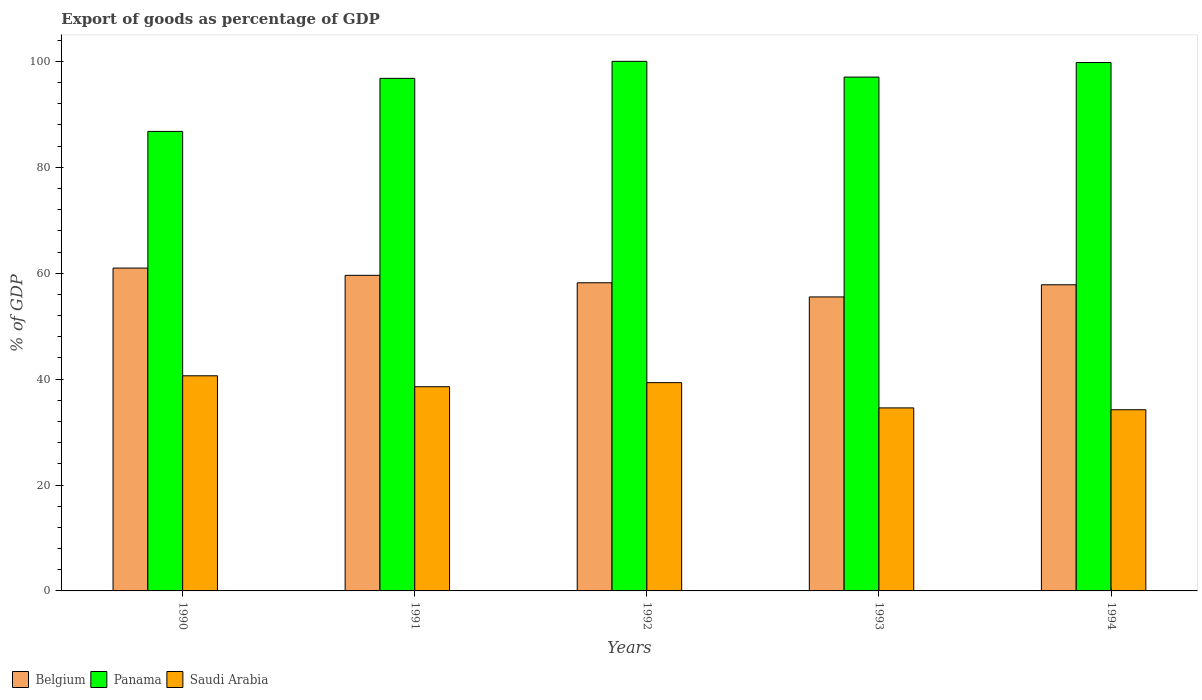Are the number of bars on each tick of the X-axis equal?
Make the answer very short. Yes. How many bars are there on the 1st tick from the right?
Your answer should be very brief. 3. In how many cases, is the number of bars for a given year not equal to the number of legend labels?
Give a very brief answer. 0. What is the export of goods as percentage of GDP in Saudi Arabia in 1994?
Your answer should be compact. 34.22. Across all years, what is the maximum export of goods as percentage of GDP in Panama?
Make the answer very short. 100.01. Across all years, what is the minimum export of goods as percentage of GDP in Saudi Arabia?
Offer a very short reply. 34.22. In which year was the export of goods as percentage of GDP in Saudi Arabia minimum?
Keep it short and to the point. 1994. What is the total export of goods as percentage of GDP in Saudi Arabia in the graph?
Make the answer very short. 187.31. What is the difference between the export of goods as percentage of GDP in Belgium in 1990 and that in 1993?
Your response must be concise. 5.45. What is the difference between the export of goods as percentage of GDP in Saudi Arabia in 1992 and the export of goods as percentage of GDP in Belgium in 1991?
Make the answer very short. -20.27. What is the average export of goods as percentage of GDP in Saudi Arabia per year?
Offer a very short reply. 37.46. In the year 1991, what is the difference between the export of goods as percentage of GDP in Saudi Arabia and export of goods as percentage of GDP in Belgium?
Your answer should be compact. -21.03. What is the ratio of the export of goods as percentage of GDP in Panama in 1991 to that in 1993?
Ensure brevity in your answer.  1. Is the difference between the export of goods as percentage of GDP in Saudi Arabia in 1992 and 1993 greater than the difference between the export of goods as percentage of GDP in Belgium in 1992 and 1993?
Keep it short and to the point. Yes. What is the difference between the highest and the second highest export of goods as percentage of GDP in Panama?
Offer a very short reply. 0.23. What is the difference between the highest and the lowest export of goods as percentage of GDP in Panama?
Make the answer very short. 13.23. In how many years, is the export of goods as percentage of GDP in Panama greater than the average export of goods as percentage of GDP in Panama taken over all years?
Your answer should be very brief. 4. Is the sum of the export of goods as percentage of GDP in Saudi Arabia in 1993 and 1994 greater than the maximum export of goods as percentage of GDP in Panama across all years?
Your response must be concise. No. What does the 3rd bar from the left in 1990 represents?
Make the answer very short. Saudi Arabia. What is the difference between two consecutive major ticks on the Y-axis?
Offer a very short reply. 20. Are the values on the major ticks of Y-axis written in scientific E-notation?
Your answer should be compact. No. Where does the legend appear in the graph?
Provide a short and direct response. Bottom left. How many legend labels are there?
Offer a very short reply. 3. How are the legend labels stacked?
Provide a short and direct response. Horizontal. What is the title of the graph?
Give a very brief answer. Export of goods as percentage of GDP. Does "St. Lucia" appear as one of the legend labels in the graph?
Give a very brief answer. No. What is the label or title of the X-axis?
Your answer should be compact. Years. What is the label or title of the Y-axis?
Your response must be concise. % of GDP. What is the % of GDP of Belgium in 1990?
Your answer should be very brief. 60.97. What is the % of GDP in Panama in 1990?
Ensure brevity in your answer.  86.78. What is the % of GDP of Saudi Arabia in 1990?
Your response must be concise. 40.63. What is the % of GDP in Belgium in 1991?
Keep it short and to the point. 59.6. What is the % of GDP of Panama in 1991?
Your response must be concise. 96.8. What is the % of GDP of Saudi Arabia in 1991?
Keep it short and to the point. 38.57. What is the % of GDP in Belgium in 1992?
Offer a terse response. 58.2. What is the % of GDP in Panama in 1992?
Offer a very short reply. 100.01. What is the % of GDP in Saudi Arabia in 1992?
Your answer should be compact. 39.33. What is the % of GDP of Belgium in 1993?
Your response must be concise. 55.52. What is the % of GDP of Panama in 1993?
Make the answer very short. 97.04. What is the % of GDP of Saudi Arabia in 1993?
Your answer should be compact. 34.57. What is the % of GDP of Belgium in 1994?
Provide a short and direct response. 57.82. What is the % of GDP of Panama in 1994?
Offer a terse response. 99.79. What is the % of GDP in Saudi Arabia in 1994?
Offer a very short reply. 34.22. Across all years, what is the maximum % of GDP in Belgium?
Your answer should be very brief. 60.97. Across all years, what is the maximum % of GDP of Panama?
Provide a short and direct response. 100.01. Across all years, what is the maximum % of GDP of Saudi Arabia?
Offer a very short reply. 40.63. Across all years, what is the minimum % of GDP of Belgium?
Your answer should be very brief. 55.52. Across all years, what is the minimum % of GDP of Panama?
Give a very brief answer. 86.78. Across all years, what is the minimum % of GDP of Saudi Arabia?
Your response must be concise. 34.22. What is the total % of GDP in Belgium in the graph?
Provide a succinct answer. 292.11. What is the total % of GDP of Panama in the graph?
Ensure brevity in your answer.  480.42. What is the total % of GDP of Saudi Arabia in the graph?
Offer a terse response. 187.31. What is the difference between the % of GDP in Belgium in 1990 and that in 1991?
Provide a short and direct response. 1.37. What is the difference between the % of GDP of Panama in 1990 and that in 1991?
Your answer should be compact. -10.02. What is the difference between the % of GDP of Saudi Arabia in 1990 and that in 1991?
Keep it short and to the point. 2.06. What is the difference between the % of GDP of Belgium in 1990 and that in 1992?
Ensure brevity in your answer.  2.78. What is the difference between the % of GDP in Panama in 1990 and that in 1992?
Your answer should be compact. -13.23. What is the difference between the % of GDP of Saudi Arabia in 1990 and that in 1992?
Provide a succinct answer. 1.3. What is the difference between the % of GDP in Belgium in 1990 and that in 1993?
Your response must be concise. 5.45. What is the difference between the % of GDP in Panama in 1990 and that in 1993?
Provide a succinct answer. -10.26. What is the difference between the % of GDP of Saudi Arabia in 1990 and that in 1993?
Ensure brevity in your answer.  6.06. What is the difference between the % of GDP of Belgium in 1990 and that in 1994?
Make the answer very short. 3.16. What is the difference between the % of GDP of Panama in 1990 and that in 1994?
Provide a succinct answer. -13. What is the difference between the % of GDP in Saudi Arabia in 1990 and that in 1994?
Offer a very short reply. 6.41. What is the difference between the % of GDP in Belgium in 1991 and that in 1992?
Offer a terse response. 1.41. What is the difference between the % of GDP in Panama in 1991 and that in 1992?
Offer a terse response. -3.21. What is the difference between the % of GDP in Saudi Arabia in 1991 and that in 1992?
Provide a short and direct response. -0.76. What is the difference between the % of GDP in Belgium in 1991 and that in 1993?
Provide a succinct answer. 4.08. What is the difference between the % of GDP of Panama in 1991 and that in 1993?
Keep it short and to the point. -0.24. What is the difference between the % of GDP in Saudi Arabia in 1991 and that in 1993?
Ensure brevity in your answer.  4. What is the difference between the % of GDP of Belgium in 1991 and that in 1994?
Keep it short and to the point. 1.79. What is the difference between the % of GDP in Panama in 1991 and that in 1994?
Give a very brief answer. -2.98. What is the difference between the % of GDP of Saudi Arabia in 1991 and that in 1994?
Make the answer very short. 4.35. What is the difference between the % of GDP in Belgium in 1992 and that in 1993?
Your answer should be very brief. 2.67. What is the difference between the % of GDP in Panama in 1992 and that in 1993?
Provide a short and direct response. 2.97. What is the difference between the % of GDP of Saudi Arabia in 1992 and that in 1993?
Keep it short and to the point. 4.77. What is the difference between the % of GDP in Belgium in 1992 and that in 1994?
Give a very brief answer. 0.38. What is the difference between the % of GDP of Panama in 1992 and that in 1994?
Provide a short and direct response. 0.23. What is the difference between the % of GDP of Saudi Arabia in 1992 and that in 1994?
Keep it short and to the point. 5.12. What is the difference between the % of GDP of Belgium in 1993 and that in 1994?
Offer a very short reply. -2.29. What is the difference between the % of GDP in Panama in 1993 and that in 1994?
Keep it short and to the point. -2.75. What is the difference between the % of GDP in Saudi Arabia in 1993 and that in 1994?
Offer a very short reply. 0.35. What is the difference between the % of GDP of Belgium in 1990 and the % of GDP of Panama in 1991?
Keep it short and to the point. -35.83. What is the difference between the % of GDP in Belgium in 1990 and the % of GDP in Saudi Arabia in 1991?
Keep it short and to the point. 22.4. What is the difference between the % of GDP of Panama in 1990 and the % of GDP of Saudi Arabia in 1991?
Offer a terse response. 48.21. What is the difference between the % of GDP in Belgium in 1990 and the % of GDP in Panama in 1992?
Make the answer very short. -39.04. What is the difference between the % of GDP of Belgium in 1990 and the % of GDP of Saudi Arabia in 1992?
Offer a terse response. 21.64. What is the difference between the % of GDP in Panama in 1990 and the % of GDP in Saudi Arabia in 1992?
Provide a short and direct response. 47.45. What is the difference between the % of GDP of Belgium in 1990 and the % of GDP of Panama in 1993?
Your answer should be compact. -36.07. What is the difference between the % of GDP of Belgium in 1990 and the % of GDP of Saudi Arabia in 1993?
Give a very brief answer. 26.41. What is the difference between the % of GDP of Panama in 1990 and the % of GDP of Saudi Arabia in 1993?
Offer a terse response. 52.22. What is the difference between the % of GDP of Belgium in 1990 and the % of GDP of Panama in 1994?
Provide a succinct answer. -38.81. What is the difference between the % of GDP of Belgium in 1990 and the % of GDP of Saudi Arabia in 1994?
Keep it short and to the point. 26.76. What is the difference between the % of GDP in Panama in 1990 and the % of GDP in Saudi Arabia in 1994?
Offer a terse response. 52.57. What is the difference between the % of GDP of Belgium in 1991 and the % of GDP of Panama in 1992?
Offer a terse response. -40.41. What is the difference between the % of GDP of Belgium in 1991 and the % of GDP of Saudi Arabia in 1992?
Your response must be concise. 20.27. What is the difference between the % of GDP in Panama in 1991 and the % of GDP in Saudi Arabia in 1992?
Your answer should be very brief. 57.47. What is the difference between the % of GDP in Belgium in 1991 and the % of GDP in Panama in 1993?
Offer a terse response. -37.44. What is the difference between the % of GDP of Belgium in 1991 and the % of GDP of Saudi Arabia in 1993?
Your answer should be very brief. 25.04. What is the difference between the % of GDP of Panama in 1991 and the % of GDP of Saudi Arabia in 1993?
Offer a terse response. 62.24. What is the difference between the % of GDP of Belgium in 1991 and the % of GDP of Panama in 1994?
Your answer should be compact. -40.18. What is the difference between the % of GDP of Belgium in 1991 and the % of GDP of Saudi Arabia in 1994?
Give a very brief answer. 25.39. What is the difference between the % of GDP in Panama in 1991 and the % of GDP in Saudi Arabia in 1994?
Your answer should be compact. 62.59. What is the difference between the % of GDP of Belgium in 1992 and the % of GDP of Panama in 1993?
Offer a very short reply. -38.84. What is the difference between the % of GDP of Belgium in 1992 and the % of GDP of Saudi Arabia in 1993?
Offer a very short reply. 23.63. What is the difference between the % of GDP of Panama in 1992 and the % of GDP of Saudi Arabia in 1993?
Offer a very short reply. 65.45. What is the difference between the % of GDP in Belgium in 1992 and the % of GDP in Panama in 1994?
Your response must be concise. -41.59. What is the difference between the % of GDP of Belgium in 1992 and the % of GDP of Saudi Arabia in 1994?
Your answer should be compact. 23.98. What is the difference between the % of GDP in Panama in 1992 and the % of GDP in Saudi Arabia in 1994?
Offer a terse response. 65.8. What is the difference between the % of GDP of Belgium in 1993 and the % of GDP of Panama in 1994?
Your response must be concise. -44.26. What is the difference between the % of GDP of Belgium in 1993 and the % of GDP of Saudi Arabia in 1994?
Ensure brevity in your answer.  21.31. What is the difference between the % of GDP in Panama in 1993 and the % of GDP in Saudi Arabia in 1994?
Ensure brevity in your answer.  62.82. What is the average % of GDP of Belgium per year?
Keep it short and to the point. 58.42. What is the average % of GDP of Panama per year?
Provide a succinct answer. 96.08. What is the average % of GDP in Saudi Arabia per year?
Keep it short and to the point. 37.46. In the year 1990, what is the difference between the % of GDP in Belgium and % of GDP in Panama?
Offer a very short reply. -25.81. In the year 1990, what is the difference between the % of GDP in Belgium and % of GDP in Saudi Arabia?
Your answer should be compact. 20.34. In the year 1990, what is the difference between the % of GDP of Panama and % of GDP of Saudi Arabia?
Make the answer very short. 46.15. In the year 1991, what is the difference between the % of GDP of Belgium and % of GDP of Panama?
Ensure brevity in your answer.  -37.2. In the year 1991, what is the difference between the % of GDP of Belgium and % of GDP of Saudi Arabia?
Keep it short and to the point. 21.03. In the year 1991, what is the difference between the % of GDP of Panama and % of GDP of Saudi Arabia?
Provide a succinct answer. 58.23. In the year 1992, what is the difference between the % of GDP of Belgium and % of GDP of Panama?
Your answer should be compact. -41.81. In the year 1992, what is the difference between the % of GDP in Belgium and % of GDP in Saudi Arabia?
Provide a short and direct response. 18.86. In the year 1992, what is the difference between the % of GDP in Panama and % of GDP in Saudi Arabia?
Your response must be concise. 60.68. In the year 1993, what is the difference between the % of GDP in Belgium and % of GDP in Panama?
Give a very brief answer. -41.52. In the year 1993, what is the difference between the % of GDP in Belgium and % of GDP in Saudi Arabia?
Your response must be concise. 20.96. In the year 1993, what is the difference between the % of GDP of Panama and % of GDP of Saudi Arabia?
Make the answer very short. 62.47. In the year 1994, what is the difference between the % of GDP in Belgium and % of GDP in Panama?
Your answer should be very brief. -41.97. In the year 1994, what is the difference between the % of GDP in Belgium and % of GDP in Saudi Arabia?
Offer a terse response. 23.6. In the year 1994, what is the difference between the % of GDP of Panama and % of GDP of Saudi Arabia?
Provide a succinct answer. 65.57. What is the ratio of the % of GDP of Belgium in 1990 to that in 1991?
Ensure brevity in your answer.  1.02. What is the ratio of the % of GDP of Panama in 1990 to that in 1991?
Keep it short and to the point. 0.9. What is the ratio of the % of GDP in Saudi Arabia in 1990 to that in 1991?
Your answer should be compact. 1.05. What is the ratio of the % of GDP in Belgium in 1990 to that in 1992?
Ensure brevity in your answer.  1.05. What is the ratio of the % of GDP of Panama in 1990 to that in 1992?
Your answer should be compact. 0.87. What is the ratio of the % of GDP of Saudi Arabia in 1990 to that in 1992?
Keep it short and to the point. 1.03. What is the ratio of the % of GDP in Belgium in 1990 to that in 1993?
Your answer should be very brief. 1.1. What is the ratio of the % of GDP in Panama in 1990 to that in 1993?
Ensure brevity in your answer.  0.89. What is the ratio of the % of GDP in Saudi Arabia in 1990 to that in 1993?
Offer a very short reply. 1.18. What is the ratio of the % of GDP of Belgium in 1990 to that in 1994?
Offer a very short reply. 1.05. What is the ratio of the % of GDP of Panama in 1990 to that in 1994?
Provide a succinct answer. 0.87. What is the ratio of the % of GDP in Saudi Arabia in 1990 to that in 1994?
Provide a short and direct response. 1.19. What is the ratio of the % of GDP of Belgium in 1991 to that in 1992?
Your answer should be compact. 1.02. What is the ratio of the % of GDP in Panama in 1991 to that in 1992?
Offer a very short reply. 0.97. What is the ratio of the % of GDP of Saudi Arabia in 1991 to that in 1992?
Your answer should be very brief. 0.98. What is the ratio of the % of GDP of Belgium in 1991 to that in 1993?
Keep it short and to the point. 1.07. What is the ratio of the % of GDP of Saudi Arabia in 1991 to that in 1993?
Keep it short and to the point. 1.12. What is the ratio of the % of GDP of Belgium in 1991 to that in 1994?
Provide a short and direct response. 1.03. What is the ratio of the % of GDP in Panama in 1991 to that in 1994?
Give a very brief answer. 0.97. What is the ratio of the % of GDP of Saudi Arabia in 1991 to that in 1994?
Offer a very short reply. 1.13. What is the ratio of the % of GDP of Belgium in 1992 to that in 1993?
Your answer should be very brief. 1.05. What is the ratio of the % of GDP of Panama in 1992 to that in 1993?
Provide a short and direct response. 1.03. What is the ratio of the % of GDP of Saudi Arabia in 1992 to that in 1993?
Provide a succinct answer. 1.14. What is the ratio of the % of GDP of Belgium in 1992 to that in 1994?
Provide a succinct answer. 1.01. What is the ratio of the % of GDP in Saudi Arabia in 1992 to that in 1994?
Offer a very short reply. 1.15. What is the ratio of the % of GDP of Belgium in 1993 to that in 1994?
Offer a very short reply. 0.96. What is the ratio of the % of GDP of Panama in 1993 to that in 1994?
Provide a succinct answer. 0.97. What is the ratio of the % of GDP in Saudi Arabia in 1993 to that in 1994?
Give a very brief answer. 1.01. What is the difference between the highest and the second highest % of GDP in Belgium?
Offer a terse response. 1.37. What is the difference between the highest and the second highest % of GDP of Panama?
Provide a succinct answer. 0.23. What is the difference between the highest and the second highest % of GDP in Saudi Arabia?
Ensure brevity in your answer.  1.3. What is the difference between the highest and the lowest % of GDP in Belgium?
Keep it short and to the point. 5.45. What is the difference between the highest and the lowest % of GDP of Panama?
Provide a short and direct response. 13.23. What is the difference between the highest and the lowest % of GDP in Saudi Arabia?
Your response must be concise. 6.41. 